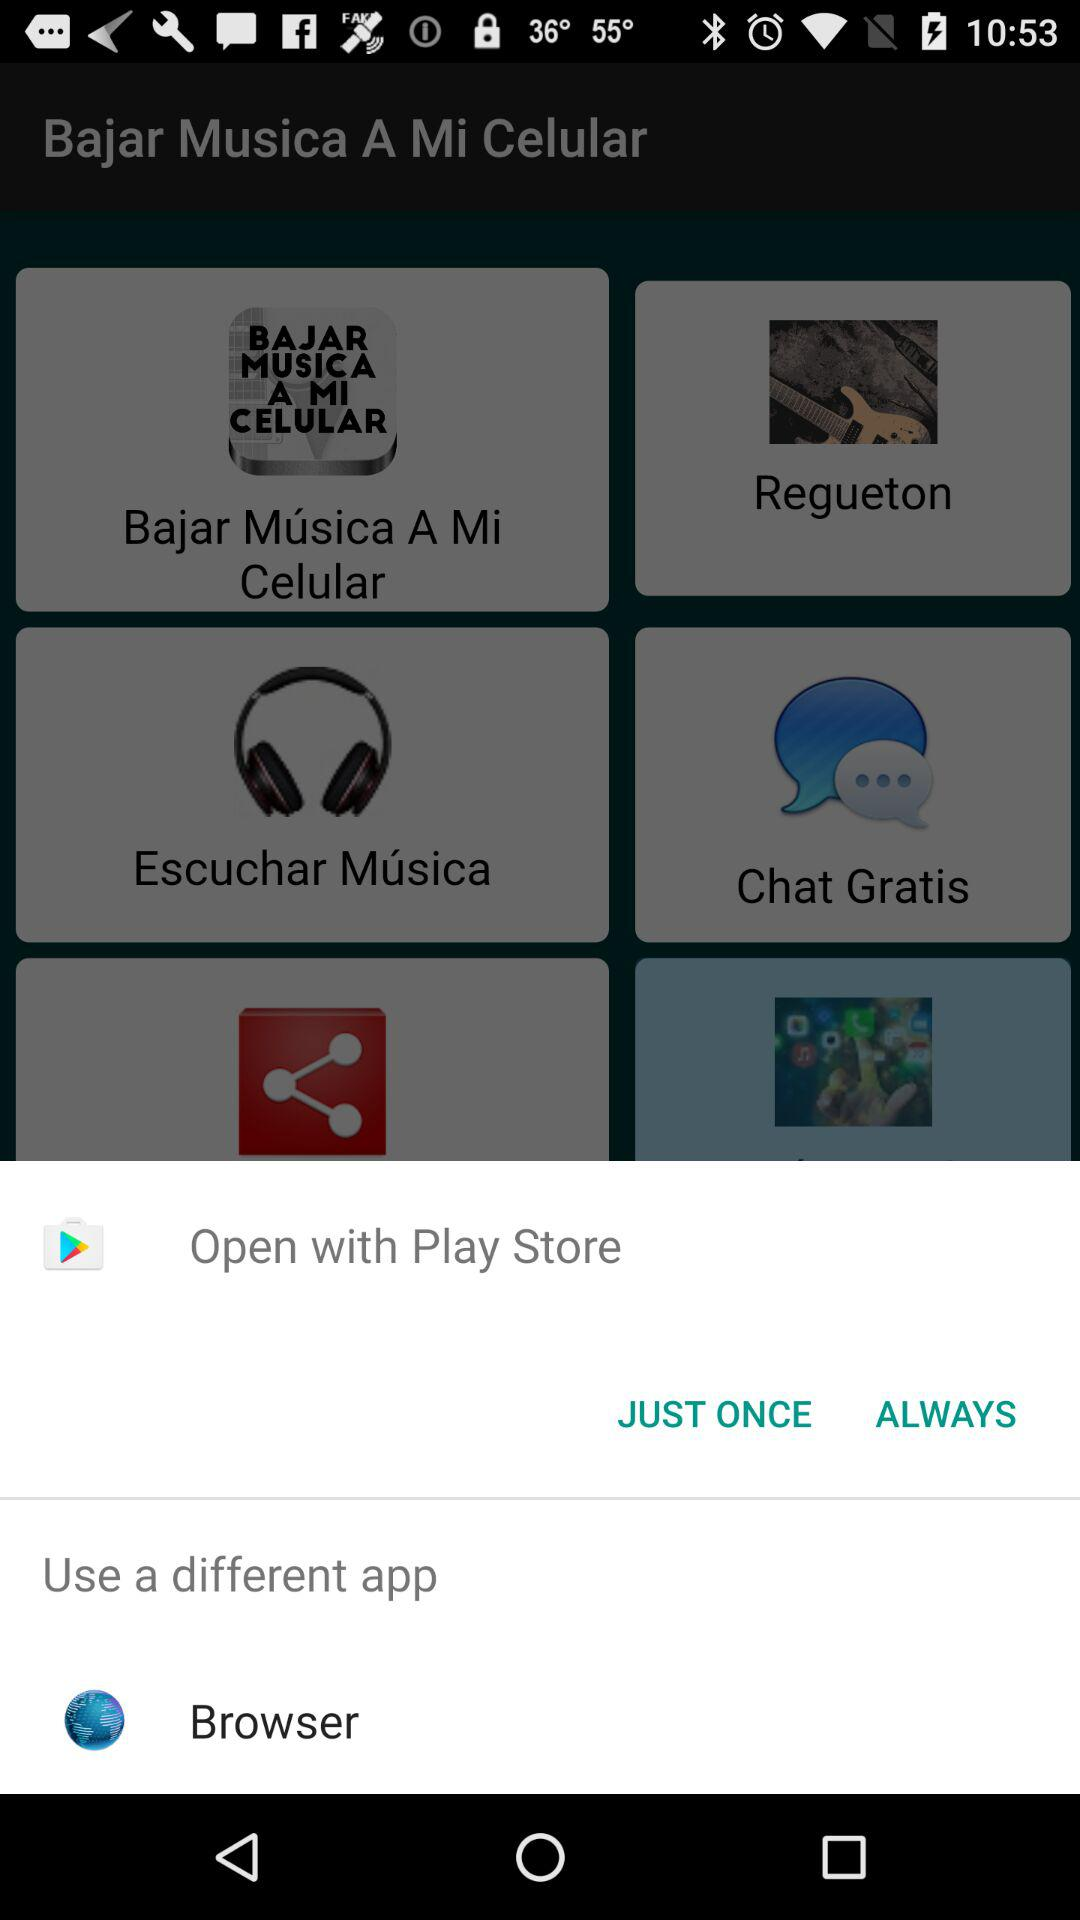What application is used to open the content? The applications used to open the content are "Play Store" and "Browser". 